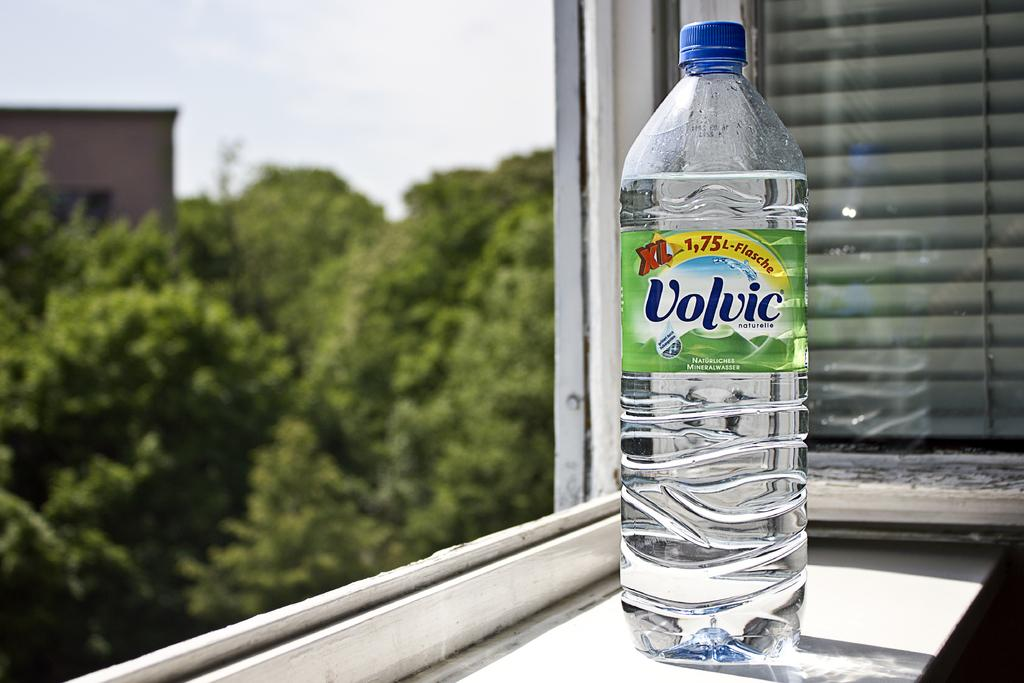What object related to hydration can be seen in the image? There is a water bottle in the image. What type of natural scenery is visible outside in the image? Trees are visible outside in the image. What type of cheese can be seen on the toes of the person in the image? There is no person or cheese present in the image. What type of school can be seen in the background of the image? There is no school visible in the image; it only features a water bottle and trees outside. 